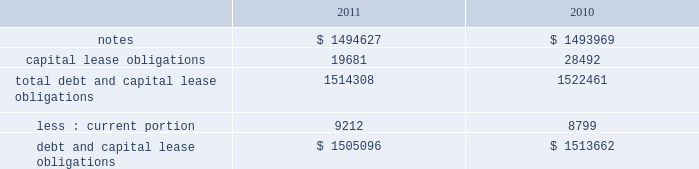Note 17 .
Debt our debt as of december 2 , 2011 and december 3 , 2010 consisted of the following ( in thousands ) : capital lease obligations total debt and capital lease obligations less : current portion debt and capital lease obligations $ 1494627 19681 1514308 $ 1505096 $ 1493969 28492 1522461 $ 1513662 in february 2010 , we issued $ 600.0 million of 3.25% ( 3.25 % ) senior notes due february 1 , 2015 ( the 201c2015 notes 201d ) and $ 900.0 million of 4.75% ( 4.75 % ) senior notes due february 1 , 2020 ( the 201c2020 notes 201d and , together with the 2015 notes , the 201cnotes 201d ) .
Our proceeds were approximately $ 1.5 billion and were net of an issuance discount of $ 6.6 million .
The notes rank equally with our other unsecured and unsubordinated indebtedness .
In addition , we incurred issuance costs of approximately $ 10.7 million .
Both the discount and issuance costs are being amortized to interest expense over the respective terms of the notes using the effective interest method .
The effective interest rate including the discount and issuance costs is 3.45% ( 3.45 % ) for the 2015 notes and 4.92% ( 4.92 % ) for the 2020 notes .
Interest is payable semi-annually , in arrears , on february 1 and august 1 , commencing on august 1 , 2010 .
During fiscal 2011 interest payments totaled $ 62.3 million .
The proceeds from the notes are available for general corporate purposes , including repayment of any balance outstanding on our credit facility .
Based on quoted market prices , the fair value of the notes was approximately $ 1.6 billion as of december 2 , 2011 .
We may redeem the notes at any time , subject to a make whole premium .
In addition , upon the occurrence of certain change of control triggering events , we may be required to repurchase the notes , at a price equal to 101% ( 101 % ) of their principal amount , plus accrued and unpaid interest to the date of repurchase .
The notes also include covenants that limit our ability to grant liens on assets and to enter into sale and leaseback transactions , subject to significant allowances .
As of december 2 , 2011 , we were in compliance with all of the covenants .
Credit agreement in august 2007 , we entered into an amendment to our credit agreement dated february 2007 ( the 201camendment 201d ) , which increased the total senior unsecured revolving facility from $ 500.0 million to $ 1.0 billion .
The amendment also permits us to request one-year extensions effective on each anniversary of the closing date of the original agreement , subject to the majority consent of the lenders .
We also retain an option to request an additional $ 500.0 million in commitments , for a maximum aggregate facility of $ 1.5 billion .
In february 2008 , we entered into a second amendment to the credit agreement dated february 26 , 2008 , which extended the maturity date of the facility by one year to february 16 , 2013 .
The facility would terminate at this date if no additional extensions have been requested and granted .
All other terms and conditions remain the same .
The facility contains a financial covenant requiring us not to exceed a certain maximum leverage ratio .
At our option , borrowings under the facility accrue interest based on either the london interbank offered rate ( 201clibor 201d ) for one , two , three or six months , or longer periods with bank consent , plus a margin according to a pricing grid tied to this financial covenant , or a base rate .
The margin is set at rates between 0.20% ( 0.20 % ) and 0.475% ( 0.475 % ) .
Commitment fees are payable on the facility at rates between 0.05% ( 0.05 % ) and 0.15% ( 0.15 % ) per year based on the same pricing grid .
The facility is available to provide loans to us and certain of our subsidiaries for general corporate purposes .
On february 1 , 2010 , we paid the outstanding balance on our credit facility and the entire $ 1.0 billion credit line under this facility remains available for borrowing .
Capital lease obligation in june 2010 , we entered into a sale-leaseback agreement to sell equipment totaling $ 32.2 million and leaseback the same equipment over a period of 43 months .
This transaction was classified as a capital lease obligation and recorded at fair value .
As of december 2 , 2011 , our capital lease obligations of $ 19.7 million includes $ 9.2 million of current debt .
Table of contents adobe systems incorporated notes to consolidated financial statements ( continued ) .
Note 17 .
Debt our debt as of december 2 , 2011 and december 3 , 2010 consisted of the following ( in thousands ) : capital lease obligations total debt and capital lease obligations less : current portion debt and capital lease obligations $ 1494627 19681 1514308 $ 1505096 $ 1493969 28492 1522461 $ 1513662 in february 2010 , we issued $ 600.0 million of 3.25% ( 3.25 % ) senior notes due february 1 , 2015 ( the 201c2015 notes 201d ) and $ 900.0 million of 4.75% ( 4.75 % ) senior notes due february 1 , 2020 ( the 201c2020 notes 201d and , together with the 2015 notes , the 201cnotes 201d ) .
Our proceeds were approximately $ 1.5 billion and were net of an issuance discount of $ 6.6 million .
The notes rank equally with our other unsecured and unsubordinated indebtedness .
In addition , we incurred issuance costs of approximately $ 10.7 million .
Both the discount and issuance costs are being amortized to interest expense over the respective terms of the notes using the effective interest method .
The effective interest rate including the discount and issuance costs is 3.45% ( 3.45 % ) for the 2015 notes and 4.92% ( 4.92 % ) for the 2020 notes .
Interest is payable semi-annually , in arrears , on february 1 and august 1 , commencing on august 1 , 2010 .
During fiscal 2011 interest payments totaled $ 62.3 million .
The proceeds from the notes are available for general corporate purposes , including repayment of any balance outstanding on our credit facility .
Based on quoted market prices , the fair value of the notes was approximately $ 1.6 billion as of december 2 , 2011 .
We may redeem the notes at any time , subject to a make whole premium .
In addition , upon the occurrence of certain change of control triggering events , we may be required to repurchase the notes , at a price equal to 101% ( 101 % ) of their principal amount , plus accrued and unpaid interest to the date of repurchase .
The notes also include covenants that limit our ability to grant liens on assets and to enter into sale and leaseback transactions , subject to significant allowances .
As of december 2 , 2011 , we were in compliance with all of the covenants .
Credit agreement in august 2007 , we entered into an amendment to our credit agreement dated february 2007 ( the 201camendment 201d ) , which increased the total senior unsecured revolving facility from $ 500.0 million to $ 1.0 billion .
The amendment also permits us to request one-year extensions effective on each anniversary of the closing date of the original agreement , subject to the majority consent of the lenders .
We also retain an option to request an additional $ 500.0 million in commitments , for a maximum aggregate facility of $ 1.5 billion .
In february 2008 , we entered into a second amendment to the credit agreement dated february 26 , 2008 , which extended the maturity date of the facility by one year to february 16 , 2013 .
The facility would terminate at this date if no additional extensions have been requested and granted .
All other terms and conditions remain the same .
The facility contains a financial covenant requiring us not to exceed a certain maximum leverage ratio .
At our option , borrowings under the facility accrue interest based on either the london interbank offered rate ( 201clibor 201d ) for one , two , three or six months , or longer periods with bank consent , plus a margin according to a pricing grid tied to this financial covenant , or a base rate .
The margin is set at rates between 0.20% ( 0.20 % ) and 0.475% ( 0.475 % ) .
Commitment fees are payable on the facility at rates between 0.05% ( 0.05 % ) and 0.15% ( 0.15 % ) per year based on the same pricing grid .
The facility is available to provide loans to us and certain of our subsidiaries for general corporate purposes .
On february 1 , 2010 , we paid the outstanding balance on our credit facility and the entire $ 1.0 billion credit line under this facility remains available for borrowing .
Capital lease obligation in june 2010 , we entered into a sale-leaseback agreement to sell equipment totaling $ 32.2 million and leaseback the same equipment over a period of 43 months .
This transaction was classified as a capital lease obligation and recorded at fair value .
As of december 2 , 2011 , our capital lease obligations of $ 19.7 million includes $ 9.2 million of current debt .
Table of contents adobe systems incorporated notes to consolidated financial statements ( continued ) .
As of december 2 , 2011 , what would capital lease obligations be in millions excluding of current debt? 
Computations: (19.7 - 9.2)
Answer: 10.5. 